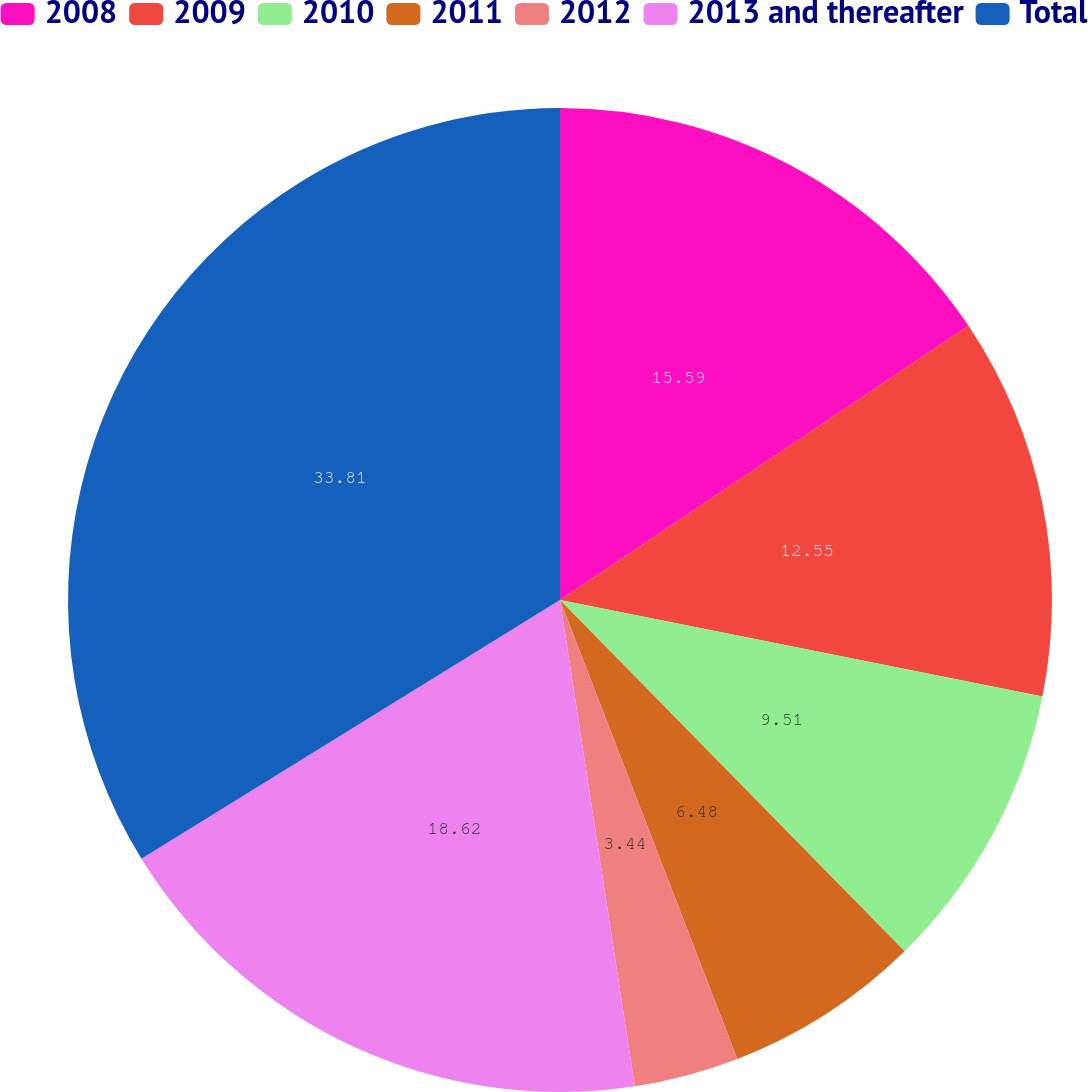<chart> <loc_0><loc_0><loc_500><loc_500><pie_chart><fcel>2008<fcel>2009<fcel>2010<fcel>2011<fcel>2012<fcel>2013 and thereafter<fcel>Total<nl><fcel>15.59%<fcel>12.55%<fcel>9.51%<fcel>6.48%<fcel>3.44%<fcel>18.62%<fcel>33.81%<nl></chart> 